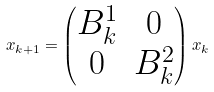<formula> <loc_0><loc_0><loc_500><loc_500>x _ { k + 1 } = \begin{pmatrix} B ^ { 1 } _ { k } & 0 \\ 0 & B ^ { 2 } _ { k } \end{pmatrix} x _ { k }</formula> 